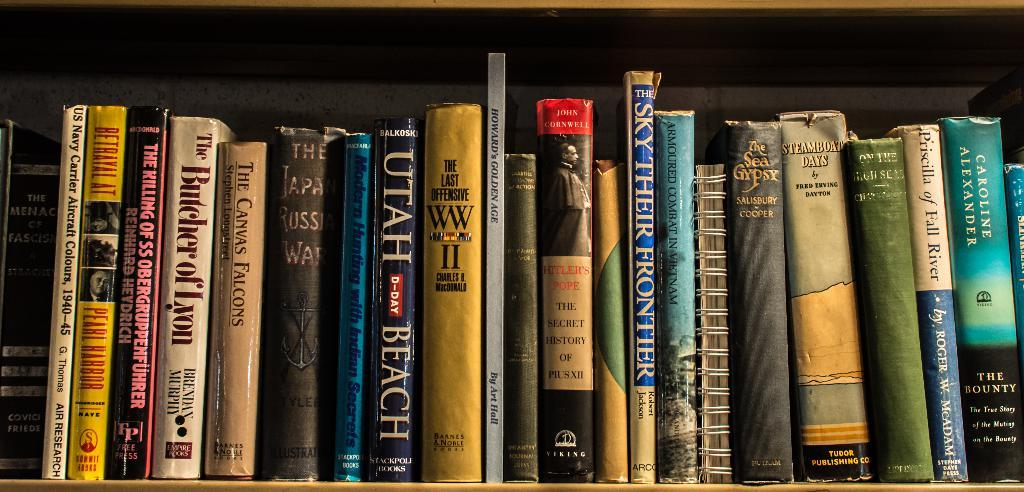<image>
Share a concise interpretation of the image provided. Many books on a shelf including "UTAH BEACH" in the middle. 